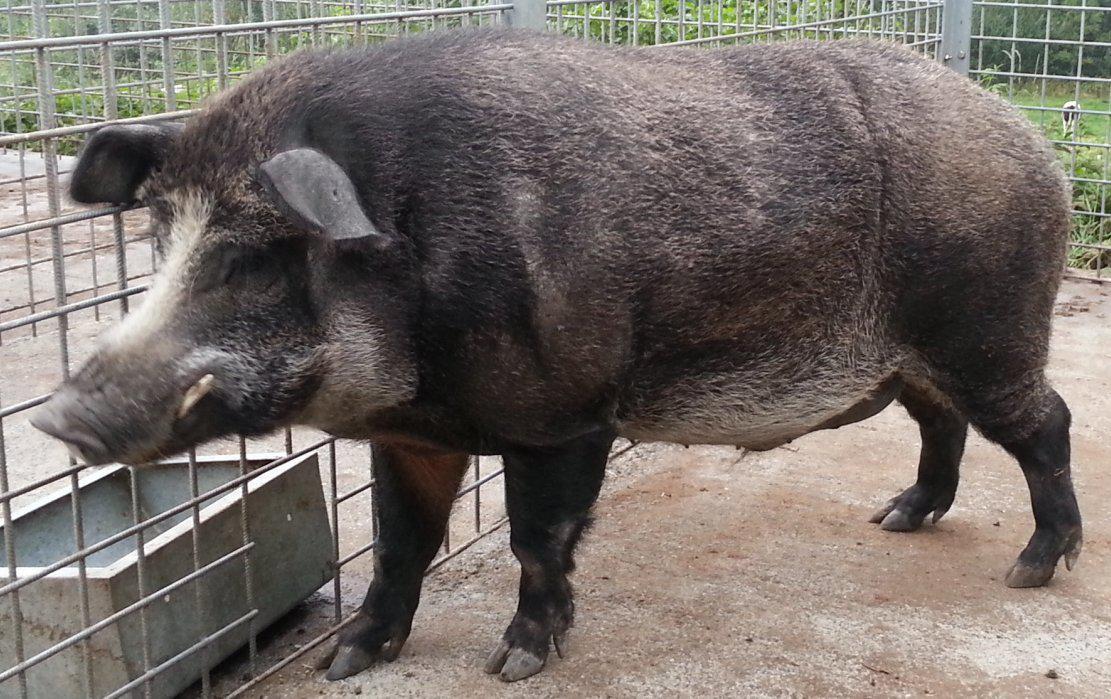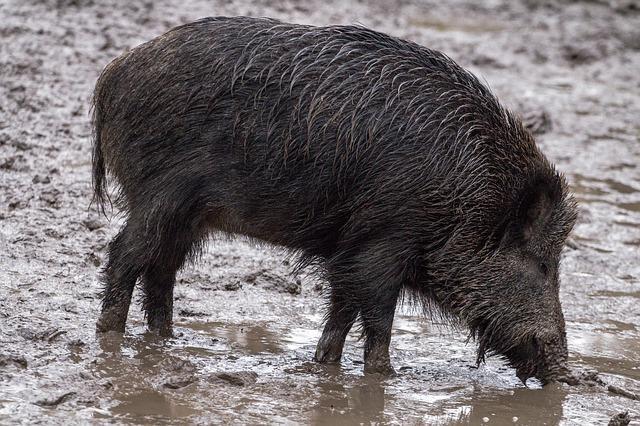The first image is the image on the left, the second image is the image on the right. Given the left and right images, does the statement "The animal in the image on the right is facing right." hold true? Answer yes or no. Yes. 